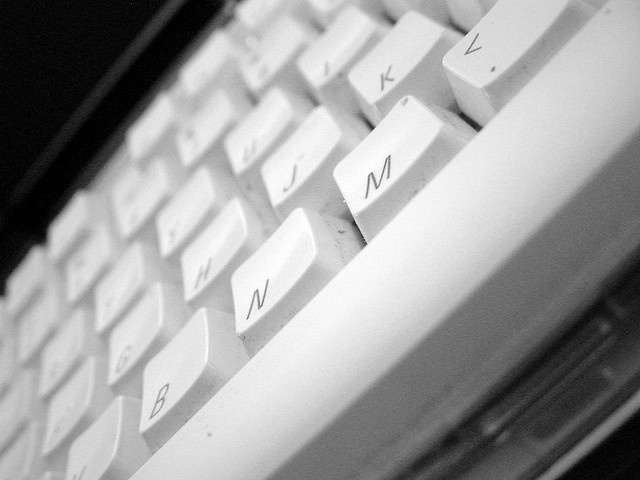Describe the objects in this image and their specific colors. I can see a keyboard in gainsboro, black, darkgray, and gray tones in this image. 